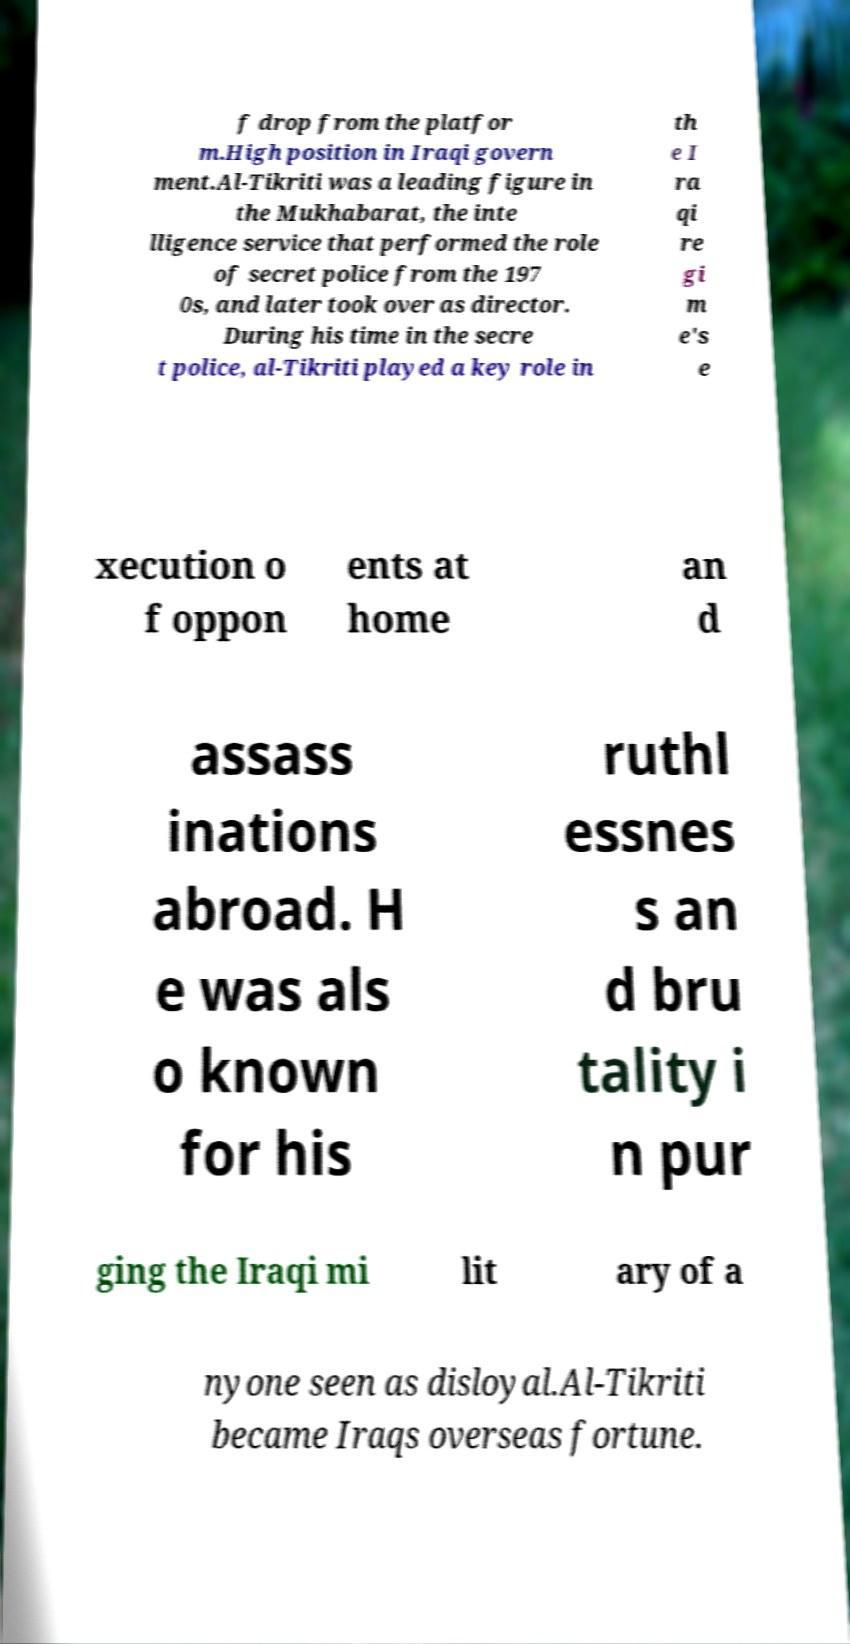I need the written content from this picture converted into text. Can you do that? f drop from the platfor m.High position in Iraqi govern ment.Al-Tikriti was a leading figure in the Mukhabarat, the inte lligence service that performed the role of secret police from the 197 0s, and later took over as director. During his time in the secre t police, al-Tikriti played a key role in th e I ra qi re gi m e's e xecution o f oppon ents at home an d assass inations abroad. H e was als o known for his ruthl essnes s an d bru tality i n pur ging the Iraqi mi lit ary of a nyone seen as disloyal.Al-Tikriti became Iraqs overseas fortune. 